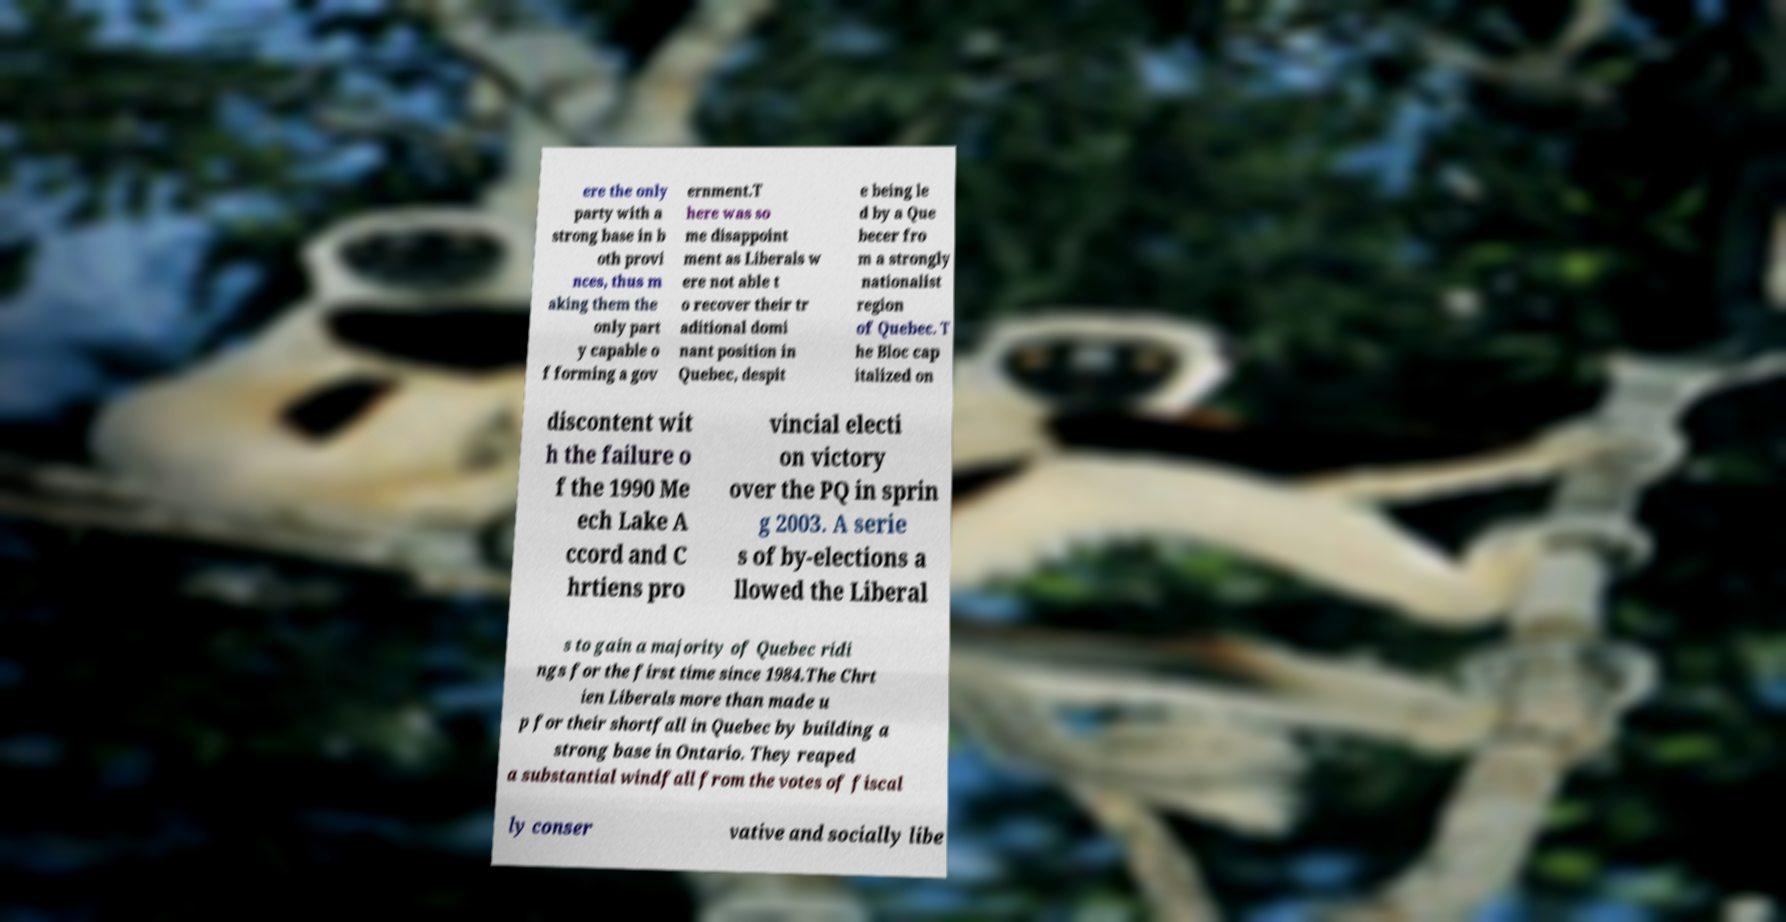Can you accurately transcribe the text from the provided image for me? ere the only party with a strong base in b oth provi nces, thus m aking them the only part y capable o f forming a gov ernment.T here was so me disappoint ment as Liberals w ere not able t o recover their tr aditional domi nant position in Quebec, despit e being le d by a Que becer fro m a strongly nationalist region of Quebec. T he Bloc cap italized on discontent wit h the failure o f the 1990 Me ech Lake A ccord and C hrtiens pro vincial electi on victory over the PQ in sprin g 2003. A serie s of by-elections a llowed the Liberal s to gain a majority of Quebec ridi ngs for the first time since 1984.The Chrt ien Liberals more than made u p for their shortfall in Quebec by building a strong base in Ontario. They reaped a substantial windfall from the votes of fiscal ly conser vative and socially libe 